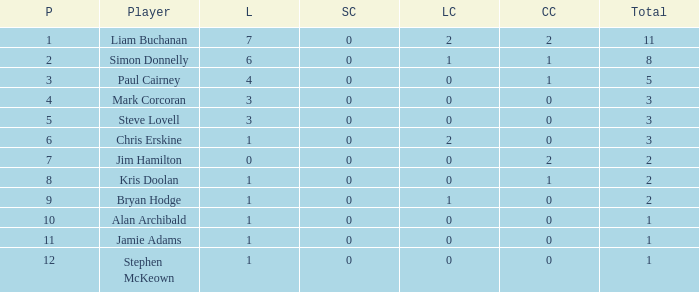How many points did player 7 score in the challenge cup? 1.0. Can you parse all the data within this table? {'header': ['P', 'Player', 'L', 'SC', 'LC', 'CC', 'Total'], 'rows': [['1', 'Liam Buchanan', '7', '0', '2', '2', '11'], ['2', 'Simon Donnelly', '6', '0', '1', '1', '8'], ['3', 'Paul Cairney', '4', '0', '0', '1', '5'], ['4', 'Mark Corcoran', '3', '0', '0', '0', '3'], ['5', 'Steve Lovell', '3', '0', '0', '0', '3'], ['6', 'Chris Erskine', '1', '0', '2', '0', '3'], ['7', 'Jim Hamilton', '0', '0', '0', '2', '2'], ['8', 'Kris Doolan', '1', '0', '0', '1', '2'], ['9', 'Bryan Hodge', '1', '0', '1', '0', '2'], ['10', 'Alan Archibald', '1', '0', '0', '0', '1'], ['11', 'Jamie Adams', '1', '0', '0', '0', '1'], ['12', 'Stephen McKeown', '1', '0', '0', '0', '1']]} 